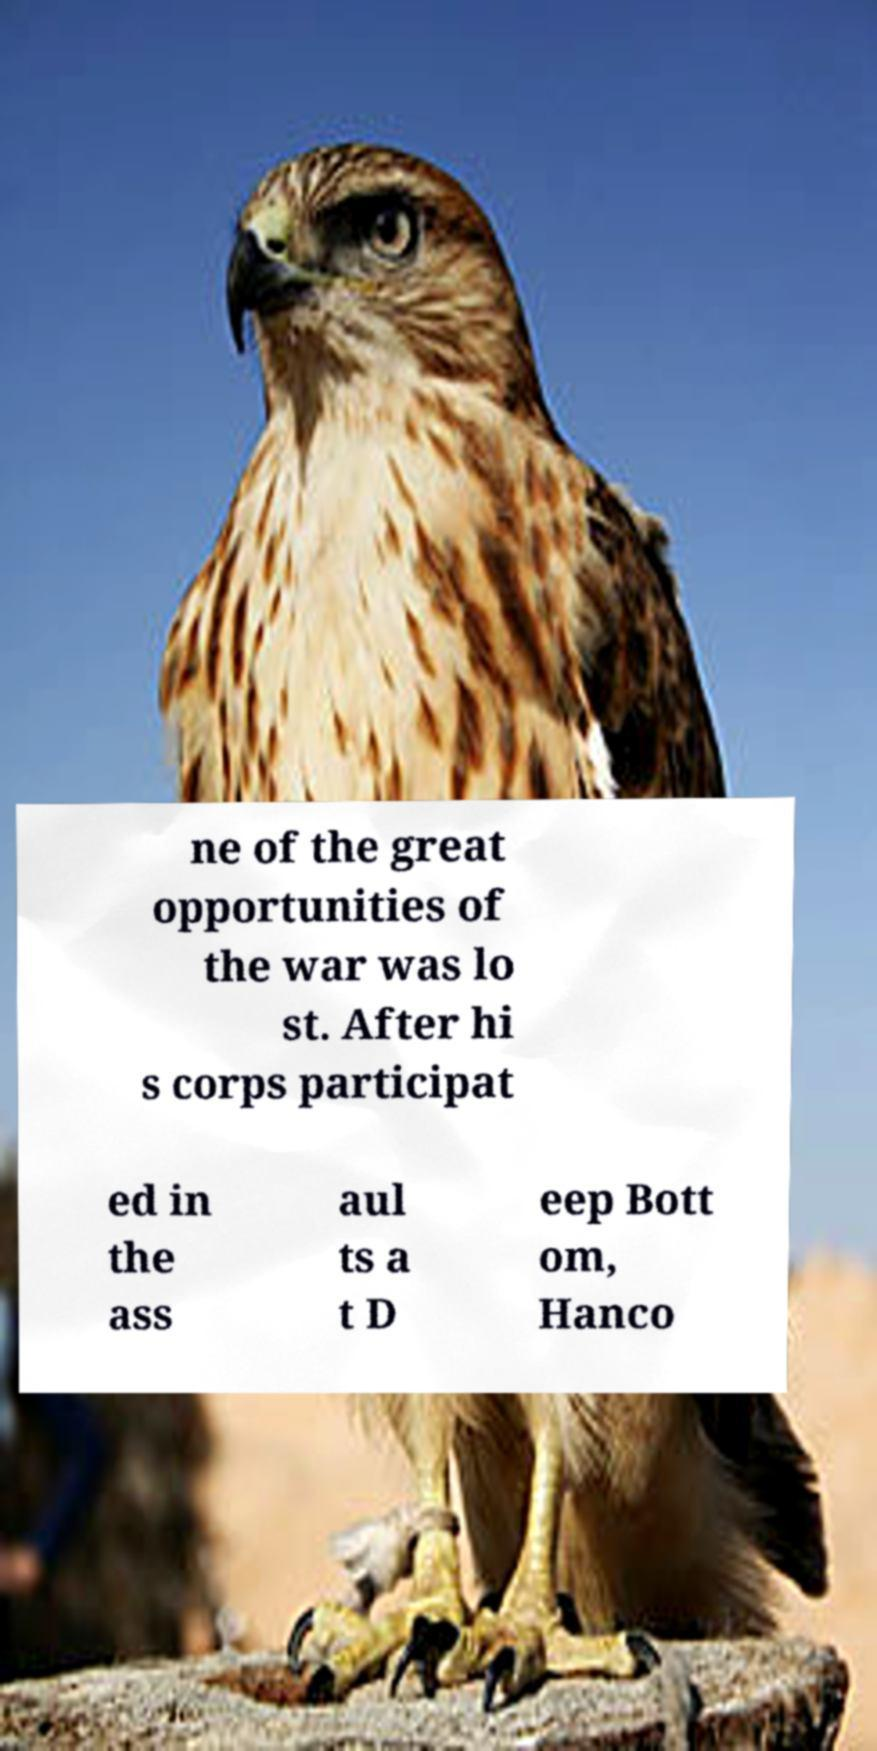Can you accurately transcribe the text from the provided image for me? ne of the great opportunities of the war was lo st. After hi s corps participat ed in the ass aul ts a t D eep Bott om, Hanco 